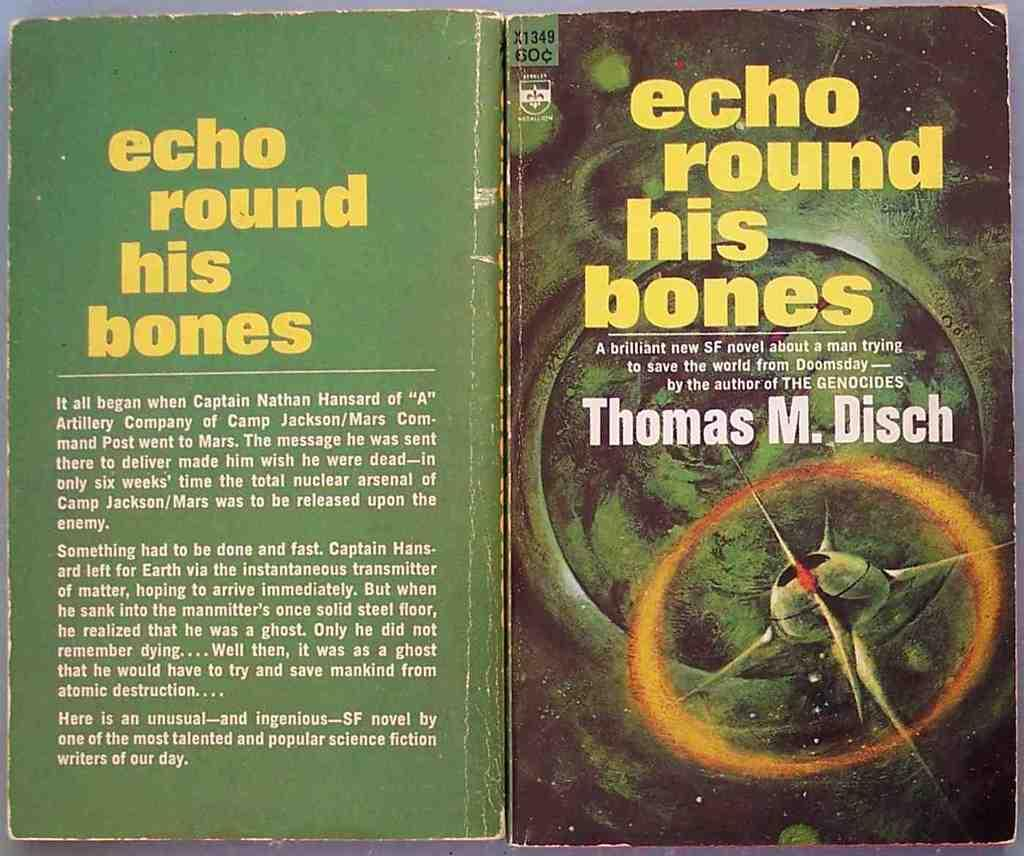<image>
Render a clear and concise summary of the photo. Thomas M. Disch has written a science fiction book. 